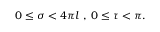Convert formula to latex. <formula><loc_0><loc_0><loc_500><loc_500>0 \leq \sigma < 4 \pi l \, , \, 0 \leq \tau < \pi .</formula> 